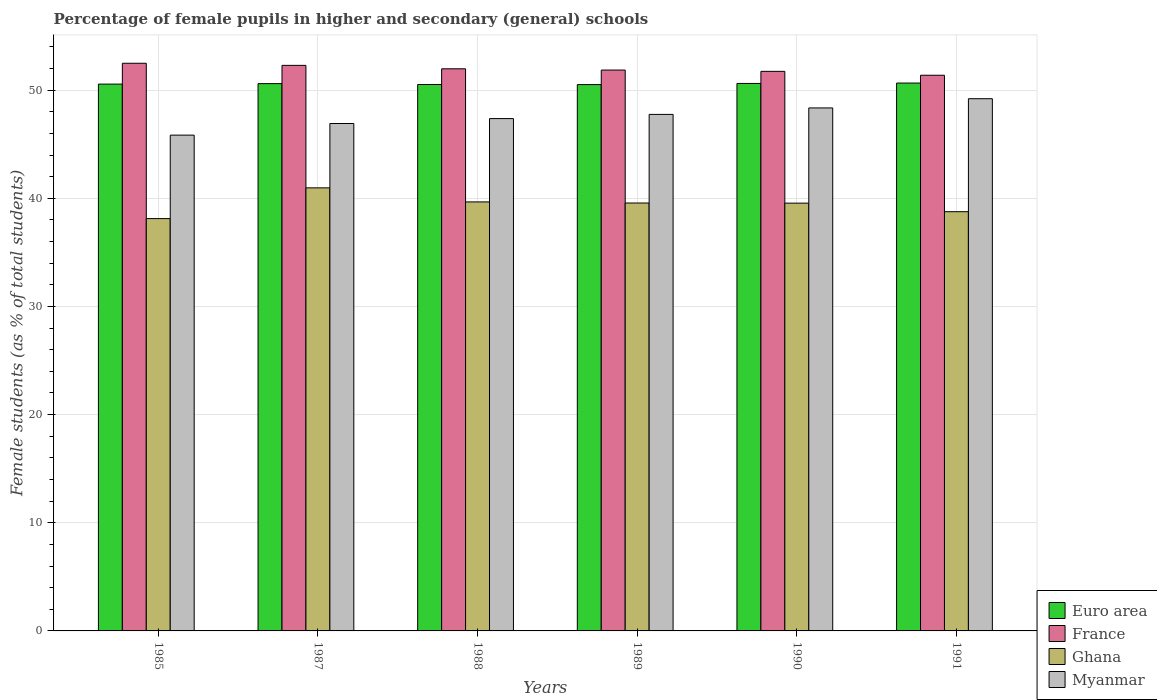How many groups of bars are there?
Make the answer very short. 6. Are the number of bars on each tick of the X-axis equal?
Your response must be concise. Yes. How many bars are there on the 2nd tick from the left?
Keep it short and to the point. 4. What is the label of the 5th group of bars from the left?
Your response must be concise. 1990. What is the percentage of female pupils in higher and secondary schools in France in 1989?
Keep it short and to the point. 51.86. Across all years, what is the maximum percentage of female pupils in higher and secondary schools in Euro area?
Make the answer very short. 50.65. Across all years, what is the minimum percentage of female pupils in higher and secondary schools in Ghana?
Keep it short and to the point. 38.12. What is the total percentage of female pupils in higher and secondary schools in Euro area in the graph?
Your answer should be very brief. 303.46. What is the difference between the percentage of female pupils in higher and secondary schools in Euro area in 1988 and that in 1991?
Offer a very short reply. -0.13. What is the difference between the percentage of female pupils in higher and secondary schools in Ghana in 1987 and the percentage of female pupils in higher and secondary schools in Myanmar in 1991?
Offer a terse response. -8.24. What is the average percentage of female pupils in higher and secondary schools in Ghana per year?
Provide a succinct answer. 39.44. In the year 1991, what is the difference between the percentage of female pupils in higher and secondary schools in Myanmar and percentage of female pupils in higher and secondary schools in Euro area?
Provide a short and direct response. -1.45. In how many years, is the percentage of female pupils in higher and secondary schools in Myanmar greater than 36 %?
Ensure brevity in your answer.  6. What is the ratio of the percentage of female pupils in higher and secondary schools in Ghana in 1987 to that in 1991?
Give a very brief answer. 1.06. Is the percentage of female pupils in higher and secondary schools in Myanmar in 1985 less than that in 1991?
Give a very brief answer. Yes. What is the difference between the highest and the second highest percentage of female pupils in higher and secondary schools in Myanmar?
Your response must be concise. 0.85. What is the difference between the highest and the lowest percentage of female pupils in higher and secondary schools in Myanmar?
Offer a very short reply. 3.37. In how many years, is the percentage of female pupils in higher and secondary schools in Ghana greater than the average percentage of female pupils in higher and secondary schools in Ghana taken over all years?
Your response must be concise. 4. Is the sum of the percentage of female pupils in higher and secondary schools in Myanmar in 1985 and 1991 greater than the maximum percentage of female pupils in higher and secondary schools in France across all years?
Offer a terse response. Yes. Is it the case that in every year, the sum of the percentage of female pupils in higher and secondary schools in France and percentage of female pupils in higher and secondary schools in Ghana is greater than the sum of percentage of female pupils in higher and secondary schools in Myanmar and percentage of female pupils in higher and secondary schools in Euro area?
Keep it short and to the point. No. What does the 3rd bar from the left in 1985 represents?
Offer a very short reply. Ghana. Is it the case that in every year, the sum of the percentage of female pupils in higher and secondary schools in Euro area and percentage of female pupils in higher and secondary schools in Myanmar is greater than the percentage of female pupils in higher and secondary schools in Ghana?
Make the answer very short. Yes. How many bars are there?
Ensure brevity in your answer.  24. How many years are there in the graph?
Your answer should be compact. 6. How many legend labels are there?
Offer a very short reply. 4. What is the title of the graph?
Your response must be concise. Percentage of female pupils in higher and secondary (general) schools. What is the label or title of the X-axis?
Offer a very short reply. Years. What is the label or title of the Y-axis?
Ensure brevity in your answer.  Female students (as % of total students). What is the Female students (as % of total students) of Euro area in 1985?
Keep it short and to the point. 50.56. What is the Female students (as % of total students) in France in 1985?
Give a very brief answer. 52.48. What is the Female students (as % of total students) of Ghana in 1985?
Offer a terse response. 38.12. What is the Female students (as % of total students) in Myanmar in 1985?
Offer a very short reply. 45.84. What is the Female students (as % of total students) in Euro area in 1987?
Offer a very short reply. 50.6. What is the Female students (as % of total students) in France in 1987?
Your response must be concise. 52.29. What is the Female students (as % of total students) of Ghana in 1987?
Offer a terse response. 40.96. What is the Female students (as % of total students) in Myanmar in 1987?
Provide a succinct answer. 46.91. What is the Female students (as % of total students) in Euro area in 1988?
Your answer should be compact. 50.52. What is the Female students (as % of total students) in France in 1988?
Make the answer very short. 51.97. What is the Female students (as % of total students) of Ghana in 1988?
Keep it short and to the point. 39.66. What is the Female students (as % of total students) of Myanmar in 1988?
Your answer should be compact. 47.37. What is the Female students (as % of total students) in Euro area in 1989?
Ensure brevity in your answer.  50.51. What is the Female students (as % of total students) in France in 1989?
Provide a succinct answer. 51.86. What is the Female students (as % of total students) of Ghana in 1989?
Keep it short and to the point. 39.56. What is the Female students (as % of total students) of Myanmar in 1989?
Offer a terse response. 47.75. What is the Female students (as % of total students) in Euro area in 1990?
Offer a terse response. 50.62. What is the Female students (as % of total students) in France in 1990?
Your answer should be very brief. 51.74. What is the Female students (as % of total students) of Ghana in 1990?
Ensure brevity in your answer.  39.55. What is the Female students (as % of total students) of Myanmar in 1990?
Keep it short and to the point. 48.35. What is the Female students (as % of total students) in Euro area in 1991?
Ensure brevity in your answer.  50.65. What is the Female students (as % of total students) of France in 1991?
Ensure brevity in your answer.  51.38. What is the Female students (as % of total students) of Ghana in 1991?
Keep it short and to the point. 38.76. What is the Female students (as % of total students) in Myanmar in 1991?
Make the answer very short. 49.21. Across all years, what is the maximum Female students (as % of total students) of Euro area?
Make the answer very short. 50.65. Across all years, what is the maximum Female students (as % of total students) of France?
Offer a very short reply. 52.48. Across all years, what is the maximum Female students (as % of total students) of Ghana?
Provide a succinct answer. 40.96. Across all years, what is the maximum Female students (as % of total students) in Myanmar?
Keep it short and to the point. 49.21. Across all years, what is the minimum Female students (as % of total students) in Euro area?
Make the answer very short. 50.51. Across all years, what is the minimum Female students (as % of total students) in France?
Provide a short and direct response. 51.38. Across all years, what is the minimum Female students (as % of total students) in Ghana?
Make the answer very short. 38.12. Across all years, what is the minimum Female students (as % of total students) of Myanmar?
Make the answer very short. 45.84. What is the total Female students (as % of total students) in Euro area in the graph?
Your answer should be very brief. 303.46. What is the total Female students (as % of total students) in France in the graph?
Your answer should be very brief. 311.71. What is the total Female students (as % of total students) in Ghana in the graph?
Ensure brevity in your answer.  236.62. What is the total Female students (as % of total students) in Myanmar in the graph?
Offer a terse response. 285.44. What is the difference between the Female students (as % of total students) of Euro area in 1985 and that in 1987?
Ensure brevity in your answer.  -0.04. What is the difference between the Female students (as % of total students) in France in 1985 and that in 1987?
Your answer should be compact. 0.2. What is the difference between the Female students (as % of total students) in Ghana in 1985 and that in 1987?
Ensure brevity in your answer.  -2.84. What is the difference between the Female students (as % of total students) in Myanmar in 1985 and that in 1987?
Your response must be concise. -1.08. What is the difference between the Female students (as % of total students) of Euro area in 1985 and that in 1988?
Your answer should be compact. 0.04. What is the difference between the Female students (as % of total students) in France in 1985 and that in 1988?
Make the answer very short. 0.51. What is the difference between the Female students (as % of total students) of Ghana in 1985 and that in 1988?
Provide a short and direct response. -1.54. What is the difference between the Female students (as % of total students) in Myanmar in 1985 and that in 1988?
Provide a succinct answer. -1.53. What is the difference between the Female students (as % of total students) of Euro area in 1985 and that in 1989?
Your answer should be very brief. 0.04. What is the difference between the Female students (as % of total students) of France in 1985 and that in 1989?
Ensure brevity in your answer.  0.63. What is the difference between the Female students (as % of total students) in Ghana in 1985 and that in 1989?
Give a very brief answer. -1.44. What is the difference between the Female students (as % of total students) of Myanmar in 1985 and that in 1989?
Offer a very short reply. -1.92. What is the difference between the Female students (as % of total students) in Euro area in 1985 and that in 1990?
Your answer should be compact. -0.06. What is the difference between the Female students (as % of total students) in France in 1985 and that in 1990?
Your answer should be very brief. 0.75. What is the difference between the Female students (as % of total students) in Ghana in 1985 and that in 1990?
Give a very brief answer. -1.43. What is the difference between the Female students (as % of total students) in Myanmar in 1985 and that in 1990?
Offer a very short reply. -2.52. What is the difference between the Female students (as % of total students) in Euro area in 1985 and that in 1991?
Offer a terse response. -0.1. What is the difference between the Female students (as % of total students) in France in 1985 and that in 1991?
Offer a very short reply. 1.11. What is the difference between the Female students (as % of total students) of Ghana in 1985 and that in 1991?
Keep it short and to the point. -0.64. What is the difference between the Female students (as % of total students) in Myanmar in 1985 and that in 1991?
Keep it short and to the point. -3.37. What is the difference between the Female students (as % of total students) of Euro area in 1987 and that in 1988?
Your response must be concise. 0.08. What is the difference between the Female students (as % of total students) in France in 1987 and that in 1988?
Your answer should be compact. 0.32. What is the difference between the Female students (as % of total students) in Ghana in 1987 and that in 1988?
Your response must be concise. 1.3. What is the difference between the Female students (as % of total students) in Myanmar in 1987 and that in 1988?
Keep it short and to the point. -0.45. What is the difference between the Female students (as % of total students) in Euro area in 1987 and that in 1989?
Offer a terse response. 0.09. What is the difference between the Female students (as % of total students) of France in 1987 and that in 1989?
Make the answer very short. 0.43. What is the difference between the Female students (as % of total students) in Ghana in 1987 and that in 1989?
Your response must be concise. 1.4. What is the difference between the Female students (as % of total students) of Myanmar in 1987 and that in 1989?
Provide a succinct answer. -0.84. What is the difference between the Female students (as % of total students) in Euro area in 1987 and that in 1990?
Provide a short and direct response. -0.02. What is the difference between the Female students (as % of total students) of France in 1987 and that in 1990?
Ensure brevity in your answer.  0.55. What is the difference between the Female students (as % of total students) in Ghana in 1987 and that in 1990?
Provide a succinct answer. 1.41. What is the difference between the Female students (as % of total students) of Myanmar in 1987 and that in 1990?
Give a very brief answer. -1.44. What is the difference between the Female students (as % of total students) of Euro area in 1987 and that in 1991?
Make the answer very short. -0.05. What is the difference between the Female students (as % of total students) in France in 1987 and that in 1991?
Give a very brief answer. 0.91. What is the difference between the Female students (as % of total students) of Ghana in 1987 and that in 1991?
Your answer should be very brief. 2.2. What is the difference between the Female students (as % of total students) in Myanmar in 1987 and that in 1991?
Your response must be concise. -2.29. What is the difference between the Female students (as % of total students) in Euro area in 1988 and that in 1989?
Your answer should be compact. 0.01. What is the difference between the Female students (as % of total students) in France in 1988 and that in 1989?
Make the answer very short. 0.12. What is the difference between the Female students (as % of total students) in Ghana in 1988 and that in 1989?
Provide a succinct answer. 0.1. What is the difference between the Female students (as % of total students) of Myanmar in 1988 and that in 1989?
Your answer should be very brief. -0.39. What is the difference between the Female students (as % of total students) of Euro area in 1988 and that in 1990?
Offer a very short reply. -0.1. What is the difference between the Female students (as % of total students) in France in 1988 and that in 1990?
Offer a terse response. 0.24. What is the difference between the Female students (as % of total students) in Ghana in 1988 and that in 1990?
Make the answer very short. 0.11. What is the difference between the Female students (as % of total students) in Myanmar in 1988 and that in 1990?
Ensure brevity in your answer.  -0.99. What is the difference between the Female students (as % of total students) of Euro area in 1988 and that in 1991?
Your answer should be very brief. -0.13. What is the difference between the Female students (as % of total students) in France in 1988 and that in 1991?
Your response must be concise. 0.6. What is the difference between the Female students (as % of total students) of Ghana in 1988 and that in 1991?
Offer a very short reply. 0.9. What is the difference between the Female students (as % of total students) of Myanmar in 1988 and that in 1991?
Your answer should be very brief. -1.84. What is the difference between the Female students (as % of total students) in Euro area in 1989 and that in 1990?
Provide a succinct answer. -0.11. What is the difference between the Female students (as % of total students) in France in 1989 and that in 1990?
Make the answer very short. 0.12. What is the difference between the Female students (as % of total students) in Ghana in 1989 and that in 1990?
Provide a short and direct response. 0.01. What is the difference between the Female students (as % of total students) in Myanmar in 1989 and that in 1990?
Offer a terse response. -0.6. What is the difference between the Female students (as % of total students) of Euro area in 1989 and that in 1991?
Provide a short and direct response. -0.14. What is the difference between the Female students (as % of total students) of France in 1989 and that in 1991?
Provide a short and direct response. 0.48. What is the difference between the Female students (as % of total students) in Ghana in 1989 and that in 1991?
Offer a very short reply. 0.8. What is the difference between the Female students (as % of total students) in Myanmar in 1989 and that in 1991?
Keep it short and to the point. -1.45. What is the difference between the Female students (as % of total students) in Euro area in 1990 and that in 1991?
Provide a succinct answer. -0.04. What is the difference between the Female students (as % of total students) in France in 1990 and that in 1991?
Your response must be concise. 0.36. What is the difference between the Female students (as % of total students) in Ghana in 1990 and that in 1991?
Provide a short and direct response. 0.79. What is the difference between the Female students (as % of total students) in Myanmar in 1990 and that in 1991?
Offer a very short reply. -0.85. What is the difference between the Female students (as % of total students) of Euro area in 1985 and the Female students (as % of total students) of France in 1987?
Provide a succinct answer. -1.73. What is the difference between the Female students (as % of total students) of Euro area in 1985 and the Female students (as % of total students) of Ghana in 1987?
Your answer should be compact. 9.59. What is the difference between the Female students (as % of total students) in Euro area in 1985 and the Female students (as % of total students) in Myanmar in 1987?
Your answer should be very brief. 3.64. What is the difference between the Female students (as % of total students) of France in 1985 and the Female students (as % of total students) of Ghana in 1987?
Give a very brief answer. 11.52. What is the difference between the Female students (as % of total students) of France in 1985 and the Female students (as % of total students) of Myanmar in 1987?
Provide a succinct answer. 5.57. What is the difference between the Female students (as % of total students) in Ghana in 1985 and the Female students (as % of total students) in Myanmar in 1987?
Offer a terse response. -8.79. What is the difference between the Female students (as % of total students) in Euro area in 1985 and the Female students (as % of total students) in France in 1988?
Offer a very short reply. -1.42. What is the difference between the Female students (as % of total students) of Euro area in 1985 and the Female students (as % of total students) of Ghana in 1988?
Your answer should be compact. 10.89. What is the difference between the Female students (as % of total students) of Euro area in 1985 and the Female students (as % of total students) of Myanmar in 1988?
Your answer should be compact. 3.19. What is the difference between the Female students (as % of total students) in France in 1985 and the Female students (as % of total students) in Ghana in 1988?
Offer a terse response. 12.82. What is the difference between the Female students (as % of total students) of France in 1985 and the Female students (as % of total students) of Myanmar in 1988?
Your response must be concise. 5.12. What is the difference between the Female students (as % of total students) in Ghana in 1985 and the Female students (as % of total students) in Myanmar in 1988?
Your answer should be very brief. -9.25. What is the difference between the Female students (as % of total students) of Euro area in 1985 and the Female students (as % of total students) of France in 1989?
Provide a succinct answer. -1.3. What is the difference between the Female students (as % of total students) of Euro area in 1985 and the Female students (as % of total students) of Ghana in 1989?
Offer a very short reply. 10.99. What is the difference between the Female students (as % of total students) in Euro area in 1985 and the Female students (as % of total students) in Myanmar in 1989?
Ensure brevity in your answer.  2.8. What is the difference between the Female students (as % of total students) in France in 1985 and the Female students (as % of total students) in Ghana in 1989?
Your response must be concise. 12.92. What is the difference between the Female students (as % of total students) of France in 1985 and the Female students (as % of total students) of Myanmar in 1989?
Your answer should be very brief. 4.73. What is the difference between the Female students (as % of total students) in Ghana in 1985 and the Female students (as % of total students) in Myanmar in 1989?
Your response must be concise. -9.63. What is the difference between the Female students (as % of total students) of Euro area in 1985 and the Female students (as % of total students) of France in 1990?
Ensure brevity in your answer.  -1.18. What is the difference between the Female students (as % of total students) of Euro area in 1985 and the Female students (as % of total students) of Ghana in 1990?
Provide a succinct answer. 11.01. What is the difference between the Female students (as % of total students) of Euro area in 1985 and the Female students (as % of total students) of Myanmar in 1990?
Provide a succinct answer. 2.2. What is the difference between the Female students (as % of total students) of France in 1985 and the Female students (as % of total students) of Ghana in 1990?
Make the answer very short. 12.93. What is the difference between the Female students (as % of total students) in France in 1985 and the Female students (as % of total students) in Myanmar in 1990?
Ensure brevity in your answer.  4.13. What is the difference between the Female students (as % of total students) of Ghana in 1985 and the Female students (as % of total students) of Myanmar in 1990?
Your answer should be compact. -10.23. What is the difference between the Female students (as % of total students) in Euro area in 1985 and the Female students (as % of total students) in France in 1991?
Provide a succinct answer. -0.82. What is the difference between the Female students (as % of total students) in Euro area in 1985 and the Female students (as % of total students) in Ghana in 1991?
Your answer should be very brief. 11.8. What is the difference between the Female students (as % of total students) of Euro area in 1985 and the Female students (as % of total students) of Myanmar in 1991?
Ensure brevity in your answer.  1.35. What is the difference between the Female students (as % of total students) in France in 1985 and the Female students (as % of total students) in Ghana in 1991?
Offer a terse response. 13.72. What is the difference between the Female students (as % of total students) of France in 1985 and the Female students (as % of total students) of Myanmar in 1991?
Your answer should be very brief. 3.28. What is the difference between the Female students (as % of total students) of Ghana in 1985 and the Female students (as % of total students) of Myanmar in 1991?
Ensure brevity in your answer.  -11.09. What is the difference between the Female students (as % of total students) of Euro area in 1987 and the Female students (as % of total students) of France in 1988?
Give a very brief answer. -1.37. What is the difference between the Female students (as % of total students) in Euro area in 1987 and the Female students (as % of total students) in Ghana in 1988?
Give a very brief answer. 10.94. What is the difference between the Female students (as % of total students) in Euro area in 1987 and the Female students (as % of total students) in Myanmar in 1988?
Your response must be concise. 3.23. What is the difference between the Female students (as % of total students) of France in 1987 and the Female students (as % of total students) of Ghana in 1988?
Keep it short and to the point. 12.62. What is the difference between the Female students (as % of total students) in France in 1987 and the Female students (as % of total students) in Myanmar in 1988?
Your response must be concise. 4.92. What is the difference between the Female students (as % of total students) of Ghana in 1987 and the Female students (as % of total students) of Myanmar in 1988?
Provide a short and direct response. -6.4. What is the difference between the Female students (as % of total students) in Euro area in 1987 and the Female students (as % of total students) in France in 1989?
Provide a succinct answer. -1.25. What is the difference between the Female students (as % of total students) in Euro area in 1987 and the Female students (as % of total students) in Ghana in 1989?
Your answer should be very brief. 11.04. What is the difference between the Female students (as % of total students) of Euro area in 1987 and the Female students (as % of total students) of Myanmar in 1989?
Provide a succinct answer. 2.85. What is the difference between the Female students (as % of total students) in France in 1987 and the Female students (as % of total students) in Ghana in 1989?
Offer a very short reply. 12.73. What is the difference between the Female students (as % of total students) in France in 1987 and the Female students (as % of total students) in Myanmar in 1989?
Keep it short and to the point. 4.53. What is the difference between the Female students (as % of total students) in Ghana in 1987 and the Female students (as % of total students) in Myanmar in 1989?
Your response must be concise. -6.79. What is the difference between the Female students (as % of total students) in Euro area in 1987 and the Female students (as % of total students) in France in 1990?
Your answer should be very brief. -1.14. What is the difference between the Female students (as % of total students) of Euro area in 1987 and the Female students (as % of total students) of Ghana in 1990?
Give a very brief answer. 11.05. What is the difference between the Female students (as % of total students) of Euro area in 1987 and the Female students (as % of total students) of Myanmar in 1990?
Your answer should be very brief. 2.25. What is the difference between the Female students (as % of total students) in France in 1987 and the Female students (as % of total students) in Ghana in 1990?
Provide a succinct answer. 12.74. What is the difference between the Female students (as % of total students) in France in 1987 and the Female students (as % of total students) in Myanmar in 1990?
Your answer should be very brief. 3.93. What is the difference between the Female students (as % of total students) in Ghana in 1987 and the Female students (as % of total students) in Myanmar in 1990?
Provide a succinct answer. -7.39. What is the difference between the Female students (as % of total students) of Euro area in 1987 and the Female students (as % of total students) of France in 1991?
Offer a very short reply. -0.78. What is the difference between the Female students (as % of total students) of Euro area in 1987 and the Female students (as % of total students) of Ghana in 1991?
Your response must be concise. 11.84. What is the difference between the Female students (as % of total students) of Euro area in 1987 and the Female students (as % of total students) of Myanmar in 1991?
Keep it short and to the point. 1.39. What is the difference between the Female students (as % of total students) of France in 1987 and the Female students (as % of total students) of Ghana in 1991?
Offer a very short reply. 13.53. What is the difference between the Female students (as % of total students) of France in 1987 and the Female students (as % of total students) of Myanmar in 1991?
Ensure brevity in your answer.  3.08. What is the difference between the Female students (as % of total students) in Ghana in 1987 and the Female students (as % of total students) in Myanmar in 1991?
Offer a terse response. -8.24. What is the difference between the Female students (as % of total students) of Euro area in 1988 and the Female students (as % of total students) of France in 1989?
Give a very brief answer. -1.33. What is the difference between the Female students (as % of total students) in Euro area in 1988 and the Female students (as % of total students) in Ghana in 1989?
Provide a succinct answer. 10.96. What is the difference between the Female students (as % of total students) in Euro area in 1988 and the Female students (as % of total students) in Myanmar in 1989?
Make the answer very short. 2.77. What is the difference between the Female students (as % of total students) in France in 1988 and the Female students (as % of total students) in Ghana in 1989?
Offer a terse response. 12.41. What is the difference between the Female students (as % of total students) of France in 1988 and the Female students (as % of total students) of Myanmar in 1989?
Give a very brief answer. 4.22. What is the difference between the Female students (as % of total students) in Ghana in 1988 and the Female students (as % of total students) in Myanmar in 1989?
Your response must be concise. -8.09. What is the difference between the Female students (as % of total students) in Euro area in 1988 and the Female students (as % of total students) in France in 1990?
Ensure brevity in your answer.  -1.22. What is the difference between the Female students (as % of total students) of Euro area in 1988 and the Female students (as % of total students) of Ghana in 1990?
Give a very brief answer. 10.97. What is the difference between the Female students (as % of total students) of Euro area in 1988 and the Female students (as % of total students) of Myanmar in 1990?
Your answer should be very brief. 2.17. What is the difference between the Female students (as % of total students) in France in 1988 and the Female students (as % of total students) in Ghana in 1990?
Give a very brief answer. 12.42. What is the difference between the Female students (as % of total students) in France in 1988 and the Female students (as % of total students) in Myanmar in 1990?
Provide a succinct answer. 3.62. What is the difference between the Female students (as % of total students) of Ghana in 1988 and the Female students (as % of total students) of Myanmar in 1990?
Provide a succinct answer. -8.69. What is the difference between the Female students (as % of total students) in Euro area in 1988 and the Female students (as % of total students) in France in 1991?
Offer a terse response. -0.86. What is the difference between the Female students (as % of total students) of Euro area in 1988 and the Female students (as % of total students) of Ghana in 1991?
Your answer should be compact. 11.76. What is the difference between the Female students (as % of total students) of Euro area in 1988 and the Female students (as % of total students) of Myanmar in 1991?
Make the answer very short. 1.31. What is the difference between the Female students (as % of total students) in France in 1988 and the Female students (as % of total students) in Ghana in 1991?
Your answer should be very brief. 13.21. What is the difference between the Female students (as % of total students) of France in 1988 and the Female students (as % of total students) of Myanmar in 1991?
Offer a very short reply. 2.77. What is the difference between the Female students (as % of total students) in Ghana in 1988 and the Female students (as % of total students) in Myanmar in 1991?
Your answer should be compact. -9.54. What is the difference between the Female students (as % of total students) of Euro area in 1989 and the Female students (as % of total students) of France in 1990?
Your answer should be compact. -1.22. What is the difference between the Female students (as % of total students) in Euro area in 1989 and the Female students (as % of total students) in Ghana in 1990?
Provide a short and direct response. 10.96. What is the difference between the Female students (as % of total students) of Euro area in 1989 and the Female students (as % of total students) of Myanmar in 1990?
Make the answer very short. 2.16. What is the difference between the Female students (as % of total students) of France in 1989 and the Female students (as % of total students) of Ghana in 1990?
Keep it short and to the point. 12.3. What is the difference between the Female students (as % of total students) in France in 1989 and the Female students (as % of total students) in Myanmar in 1990?
Give a very brief answer. 3.5. What is the difference between the Female students (as % of total students) of Ghana in 1989 and the Female students (as % of total students) of Myanmar in 1990?
Offer a very short reply. -8.79. What is the difference between the Female students (as % of total students) of Euro area in 1989 and the Female students (as % of total students) of France in 1991?
Your answer should be compact. -0.86. What is the difference between the Female students (as % of total students) in Euro area in 1989 and the Female students (as % of total students) in Ghana in 1991?
Your response must be concise. 11.75. What is the difference between the Female students (as % of total students) of Euro area in 1989 and the Female students (as % of total students) of Myanmar in 1991?
Give a very brief answer. 1.31. What is the difference between the Female students (as % of total students) of France in 1989 and the Female students (as % of total students) of Ghana in 1991?
Ensure brevity in your answer.  13.09. What is the difference between the Female students (as % of total students) in France in 1989 and the Female students (as % of total students) in Myanmar in 1991?
Your answer should be compact. 2.65. What is the difference between the Female students (as % of total students) in Ghana in 1989 and the Female students (as % of total students) in Myanmar in 1991?
Your response must be concise. -9.64. What is the difference between the Female students (as % of total students) of Euro area in 1990 and the Female students (as % of total students) of France in 1991?
Provide a succinct answer. -0.76. What is the difference between the Female students (as % of total students) in Euro area in 1990 and the Female students (as % of total students) in Ghana in 1991?
Ensure brevity in your answer.  11.86. What is the difference between the Female students (as % of total students) in Euro area in 1990 and the Female students (as % of total students) in Myanmar in 1991?
Offer a terse response. 1.41. What is the difference between the Female students (as % of total students) of France in 1990 and the Female students (as % of total students) of Ghana in 1991?
Your answer should be compact. 12.98. What is the difference between the Female students (as % of total students) in France in 1990 and the Female students (as % of total students) in Myanmar in 1991?
Provide a short and direct response. 2.53. What is the difference between the Female students (as % of total students) in Ghana in 1990 and the Female students (as % of total students) in Myanmar in 1991?
Provide a short and direct response. -9.66. What is the average Female students (as % of total students) of Euro area per year?
Your response must be concise. 50.58. What is the average Female students (as % of total students) of France per year?
Provide a succinct answer. 51.95. What is the average Female students (as % of total students) in Ghana per year?
Your response must be concise. 39.44. What is the average Female students (as % of total students) in Myanmar per year?
Provide a short and direct response. 47.57. In the year 1985, what is the difference between the Female students (as % of total students) in Euro area and Female students (as % of total students) in France?
Provide a succinct answer. -1.93. In the year 1985, what is the difference between the Female students (as % of total students) in Euro area and Female students (as % of total students) in Ghana?
Provide a short and direct response. 12.44. In the year 1985, what is the difference between the Female students (as % of total students) of Euro area and Female students (as % of total students) of Myanmar?
Provide a succinct answer. 4.72. In the year 1985, what is the difference between the Female students (as % of total students) in France and Female students (as % of total students) in Ghana?
Keep it short and to the point. 14.36. In the year 1985, what is the difference between the Female students (as % of total students) of France and Female students (as % of total students) of Myanmar?
Offer a very short reply. 6.65. In the year 1985, what is the difference between the Female students (as % of total students) in Ghana and Female students (as % of total students) in Myanmar?
Provide a short and direct response. -7.72. In the year 1987, what is the difference between the Female students (as % of total students) of Euro area and Female students (as % of total students) of France?
Make the answer very short. -1.69. In the year 1987, what is the difference between the Female students (as % of total students) in Euro area and Female students (as % of total students) in Ghana?
Your response must be concise. 9.64. In the year 1987, what is the difference between the Female students (as % of total students) of Euro area and Female students (as % of total students) of Myanmar?
Your response must be concise. 3.69. In the year 1987, what is the difference between the Female students (as % of total students) of France and Female students (as % of total students) of Ghana?
Ensure brevity in your answer.  11.32. In the year 1987, what is the difference between the Female students (as % of total students) of France and Female students (as % of total students) of Myanmar?
Keep it short and to the point. 5.37. In the year 1987, what is the difference between the Female students (as % of total students) in Ghana and Female students (as % of total students) in Myanmar?
Offer a very short reply. -5.95. In the year 1988, what is the difference between the Female students (as % of total students) in Euro area and Female students (as % of total students) in France?
Keep it short and to the point. -1.45. In the year 1988, what is the difference between the Female students (as % of total students) of Euro area and Female students (as % of total students) of Ghana?
Your answer should be compact. 10.86. In the year 1988, what is the difference between the Female students (as % of total students) in Euro area and Female students (as % of total students) in Myanmar?
Your answer should be very brief. 3.15. In the year 1988, what is the difference between the Female students (as % of total students) of France and Female students (as % of total students) of Ghana?
Offer a very short reply. 12.31. In the year 1988, what is the difference between the Female students (as % of total students) of France and Female students (as % of total students) of Myanmar?
Offer a terse response. 4.6. In the year 1988, what is the difference between the Female students (as % of total students) of Ghana and Female students (as % of total students) of Myanmar?
Provide a succinct answer. -7.7. In the year 1989, what is the difference between the Female students (as % of total students) in Euro area and Female students (as % of total students) in France?
Offer a very short reply. -1.34. In the year 1989, what is the difference between the Female students (as % of total students) in Euro area and Female students (as % of total students) in Ghana?
Give a very brief answer. 10.95. In the year 1989, what is the difference between the Female students (as % of total students) in Euro area and Female students (as % of total students) in Myanmar?
Keep it short and to the point. 2.76. In the year 1989, what is the difference between the Female students (as % of total students) in France and Female students (as % of total students) in Ghana?
Offer a terse response. 12.29. In the year 1989, what is the difference between the Female students (as % of total students) in France and Female students (as % of total students) in Myanmar?
Make the answer very short. 4.1. In the year 1989, what is the difference between the Female students (as % of total students) in Ghana and Female students (as % of total students) in Myanmar?
Offer a very short reply. -8.19. In the year 1990, what is the difference between the Female students (as % of total students) in Euro area and Female students (as % of total students) in France?
Give a very brief answer. -1.12. In the year 1990, what is the difference between the Female students (as % of total students) of Euro area and Female students (as % of total students) of Ghana?
Make the answer very short. 11.07. In the year 1990, what is the difference between the Female students (as % of total students) of Euro area and Female students (as % of total students) of Myanmar?
Your answer should be very brief. 2.26. In the year 1990, what is the difference between the Female students (as % of total students) of France and Female students (as % of total students) of Ghana?
Your answer should be compact. 12.18. In the year 1990, what is the difference between the Female students (as % of total students) of France and Female students (as % of total students) of Myanmar?
Make the answer very short. 3.38. In the year 1990, what is the difference between the Female students (as % of total students) in Ghana and Female students (as % of total students) in Myanmar?
Offer a very short reply. -8.8. In the year 1991, what is the difference between the Female students (as % of total students) of Euro area and Female students (as % of total students) of France?
Give a very brief answer. -0.72. In the year 1991, what is the difference between the Female students (as % of total students) of Euro area and Female students (as % of total students) of Ghana?
Your answer should be very brief. 11.89. In the year 1991, what is the difference between the Female students (as % of total students) in Euro area and Female students (as % of total students) in Myanmar?
Your answer should be compact. 1.45. In the year 1991, what is the difference between the Female students (as % of total students) in France and Female students (as % of total students) in Ghana?
Give a very brief answer. 12.62. In the year 1991, what is the difference between the Female students (as % of total students) of France and Female students (as % of total students) of Myanmar?
Your answer should be compact. 2.17. In the year 1991, what is the difference between the Female students (as % of total students) of Ghana and Female students (as % of total students) of Myanmar?
Make the answer very short. -10.45. What is the ratio of the Female students (as % of total students) in Euro area in 1985 to that in 1987?
Your answer should be compact. 1. What is the ratio of the Female students (as % of total students) in France in 1985 to that in 1987?
Provide a short and direct response. 1. What is the ratio of the Female students (as % of total students) in Ghana in 1985 to that in 1987?
Keep it short and to the point. 0.93. What is the ratio of the Female students (as % of total students) of Myanmar in 1985 to that in 1987?
Offer a terse response. 0.98. What is the ratio of the Female students (as % of total students) of Euro area in 1985 to that in 1988?
Provide a succinct answer. 1. What is the ratio of the Female students (as % of total students) in France in 1985 to that in 1988?
Your answer should be very brief. 1.01. What is the ratio of the Female students (as % of total students) in Ghana in 1985 to that in 1988?
Provide a short and direct response. 0.96. What is the ratio of the Female students (as % of total students) in Myanmar in 1985 to that in 1988?
Keep it short and to the point. 0.97. What is the ratio of the Female students (as % of total students) in France in 1985 to that in 1989?
Your answer should be compact. 1.01. What is the ratio of the Female students (as % of total students) in Ghana in 1985 to that in 1989?
Offer a terse response. 0.96. What is the ratio of the Female students (as % of total students) of Myanmar in 1985 to that in 1989?
Provide a succinct answer. 0.96. What is the ratio of the Female students (as % of total students) of Euro area in 1985 to that in 1990?
Your answer should be very brief. 1. What is the ratio of the Female students (as % of total students) in France in 1985 to that in 1990?
Your answer should be very brief. 1.01. What is the ratio of the Female students (as % of total students) in Ghana in 1985 to that in 1990?
Keep it short and to the point. 0.96. What is the ratio of the Female students (as % of total students) of Myanmar in 1985 to that in 1990?
Offer a terse response. 0.95. What is the ratio of the Female students (as % of total students) in Euro area in 1985 to that in 1991?
Your response must be concise. 1. What is the ratio of the Female students (as % of total students) of France in 1985 to that in 1991?
Keep it short and to the point. 1.02. What is the ratio of the Female students (as % of total students) of Ghana in 1985 to that in 1991?
Your answer should be very brief. 0.98. What is the ratio of the Female students (as % of total students) in Myanmar in 1985 to that in 1991?
Your response must be concise. 0.93. What is the ratio of the Female students (as % of total students) in Euro area in 1987 to that in 1988?
Provide a succinct answer. 1. What is the ratio of the Female students (as % of total students) in France in 1987 to that in 1988?
Make the answer very short. 1.01. What is the ratio of the Female students (as % of total students) in Ghana in 1987 to that in 1988?
Give a very brief answer. 1.03. What is the ratio of the Female students (as % of total students) of Myanmar in 1987 to that in 1988?
Offer a very short reply. 0.99. What is the ratio of the Female students (as % of total students) of France in 1987 to that in 1989?
Provide a short and direct response. 1.01. What is the ratio of the Female students (as % of total students) in Ghana in 1987 to that in 1989?
Your answer should be compact. 1.04. What is the ratio of the Female students (as % of total students) in Myanmar in 1987 to that in 1989?
Provide a short and direct response. 0.98. What is the ratio of the Female students (as % of total students) of France in 1987 to that in 1990?
Provide a succinct answer. 1.01. What is the ratio of the Female students (as % of total students) in Ghana in 1987 to that in 1990?
Provide a short and direct response. 1.04. What is the ratio of the Female students (as % of total students) of Myanmar in 1987 to that in 1990?
Make the answer very short. 0.97. What is the ratio of the Female students (as % of total students) of Euro area in 1987 to that in 1991?
Provide a short and direct response. 1. What is the ratio of the Female students (as % of total students) of France in 1987 to that in 1991?
Keep it short and to the point. 1.02. What is the ratio of the Female students (as % of total students) in Ghana in 1987 to that in 1991?
Make the answer very short. 1.06. What is the ratio of the Female students (as % of total students) of Myanmar in 1987 to that in 1991?
Keep it short and to the point. 0.95. What is the ratio of the Female students (as % of total students) of Euro area in 1988 to that in 1989?
Provide a short and direct response. 1. What is the ratio of the Female students (as % of total students) in Ghana in 1988 to that in 1989?
Give a very brief answer. 1. What is the ratio of the Female students (as % of total students) in Myanmar in 1988 to that in 1989?
Provide a short and direct response. 0.99. What is the ratio of the Female students (as % of total students) of Euro area in 1988 to that in 1990?
Make the answer very short. 1. What is the ratio of the Female students (as % of total students) in Ghana in 1988 to that in 1990?
Your response must be concise. 1. What is the ratio of the Female students (as % of total students) in Myanmar in 1988 to that in 1990?
Make the answer very short. 0.98. What is the ratio of the Female students (as % of total students) of Euro area in 1988 to that in 1991?
Your answer should be compact. 1. What is the ratio of the Female students (as % of total students) in France in 1988 to that in 1991?
Keep it short and to the point. 1.01. What is the ratio of the Female students (as % of total students) of Ghana in 1988 to that in 1991?
Your response must be concise. 1.02. What is the ratio of the Female students (as % of total students) of Myanmar in 1988 to that in 1991?
Make the answer very short. 0.96. What is the ratio of the Female students (as % of total students) of Euro area in 1989 to that in 1990?
Offer a terse response. 1. What is the ratio of the Female students (as % of total students) of Myanmar in 1989 to that in 1990?
Make the answer very short. 0.99. What is the ratio of the Female students (as % of total students) in Euro area in 1989 to that in 1991?
Provide a succinct answer. 1. What is the ratio of the Female students (as % of total students) of France in 1989 to that in 1991?
Provide a short and direct response. 1.01. What is the ratio of the Female students (as % of total students) in Ghana in 1989 to that in 1991?
Provide a short and direct response. 1.02. What is the ratio of the Female students (as % of total students) of Myanmar in 1989 to that in 1991?
Provide a short and direct response. 0.97. What is the ratio of the Female students (as % of total students) in France in 1990 to that in 1991?
Ensure brevity in your answer.  1.01. What is the ratio of the Female students (as % of total students) of Ghana in 1990 to that in 1991?
Your answer should be compact. 1.02. What is the ratio of the Female students (as % of total students) of Myanmar in 1990 to that in 1991?
Offer a very short reply. 0.98. What is the difference between the highest and the second highest Female students (as % of total students) of Euro area?
Give a very brief answer. 0.04. What is the difference between the highest and the second highest Female students (as % of total students) of France?
Provide a succinct answer. 0.2. What is the difference between the highest and the second highest Female students (as % of total students) in Ghana?
Offer a very short reply. 1.3. What is the difference between the highest and the second highest Female students (as % of total students) in Myanmar?
Offer a very short reply. 0.85. What is the difference between the highest and the lowest Female students (as % of total students) of Euro area?
Provide a short and direct response. 0.14. What is the difference between the highest and the lowest Female students (as % of total students) in France?
Provide a succinct answer. 1.11. What is the difference between the highest and the lowest Female students (as % of total students) in Ghana?
Your answer should be compact. 2.84. What is the difference between the highest and the lowest Female students (as % of total students) of Myanmar?
Make the answer very short. 3.37. 